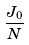<formula> <loc_0><loc_0><loc_500><loc_500>\frac { J _ { 0 } } { N }</formula> 